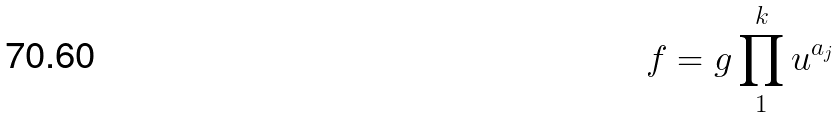<formula> <loc_0><loc_0><loc_500><loc_500>f = g \prod _ { 1 } ^ { k } u ^ { a _ { j } }</formula> 